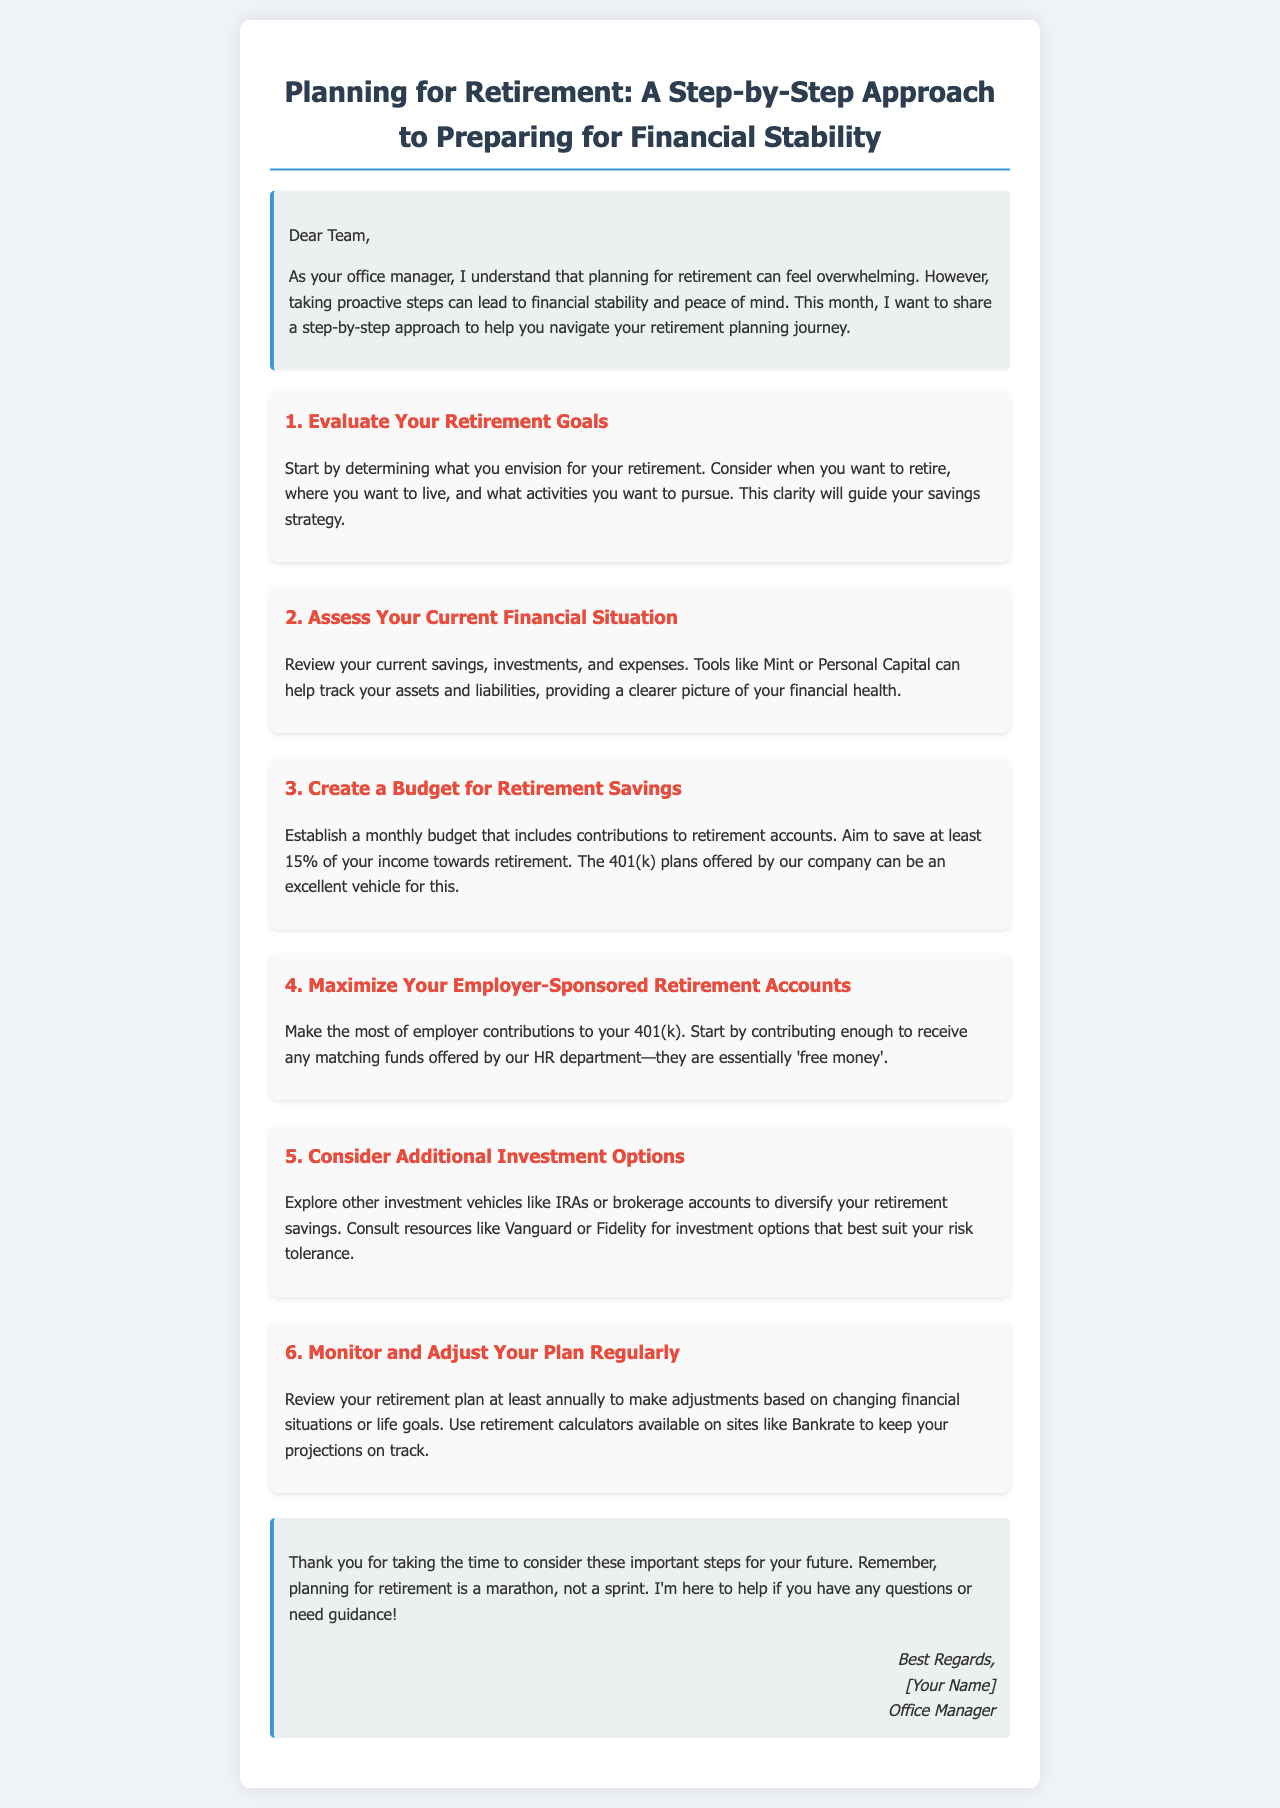What is the title of the newsletter? The title of the newsletter is prominently displayed at the top, stating the topic.
Answer: Planning for Retirement: A Step-by-Step Approach to Preparing for Financial Stability What is the first step in retirement planning? The first step is outlined in the document as a guide to help the readers understand the initial action they should take.
Answer: Evaluate Your Retirement Goals What percentage of income should be saved towards retirement? The newsletter provides specific guidance on the percentage of income that should be allocated towards retirement savings.
Answer: 15% What tool is recommended for tracking financial health? The document suggests specific tools that can help readers assess their current financial situation effectively.
Answer: Mint or Personal Capital What is the main purpose of the employer-sponsored retirement accounts? The newsletter implies the advantage of participating in employer-sponsored accounts by providing additional funds toward retirement savings.
Answer: Free money How often should the retirement plan be reviewed? The guideline suggests a frequency for reconsideration of the retirement strategy to adapt to changing circumstances.
Answer: Annually What does the newsletter suggest to diversify retirement savings? The document mentions various options to expand investment strategies beyond the basic retirement accounts.
Answer: IRAs or brokerage accounts What is emphasized about retirement planning in the closing section? The final thoughts reinforce the overall mindset required for effective retirement preparation, as stated in the text.
Answer: Marathon, not a sprint 